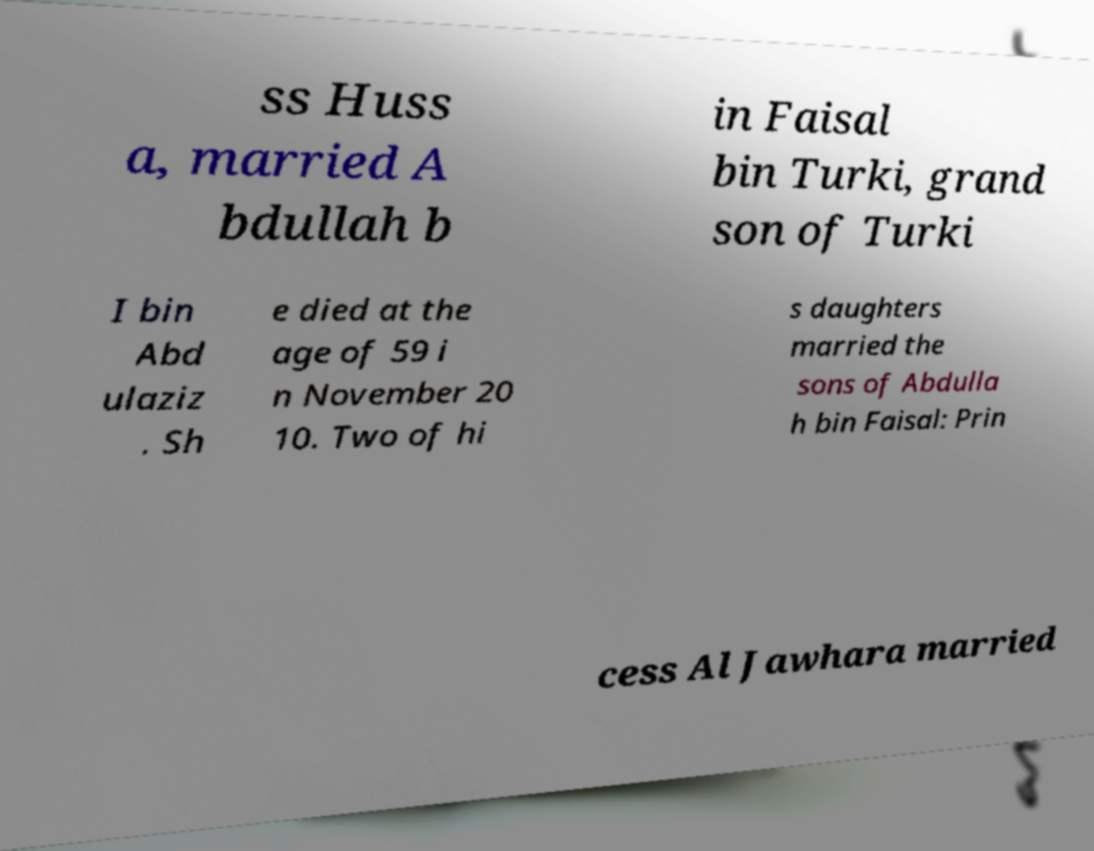Please identify and transcribe the text found in this image. ss Huss a, married A bdullah b in Faisal bin Turki, grand son of Turki I bin Abd ulaziz . Sh e died at the age of 59 i n November 20 10. Two of hi s daughters married the sons of Abdulla h bin Faisal: Prin cess Al Jawhara married 